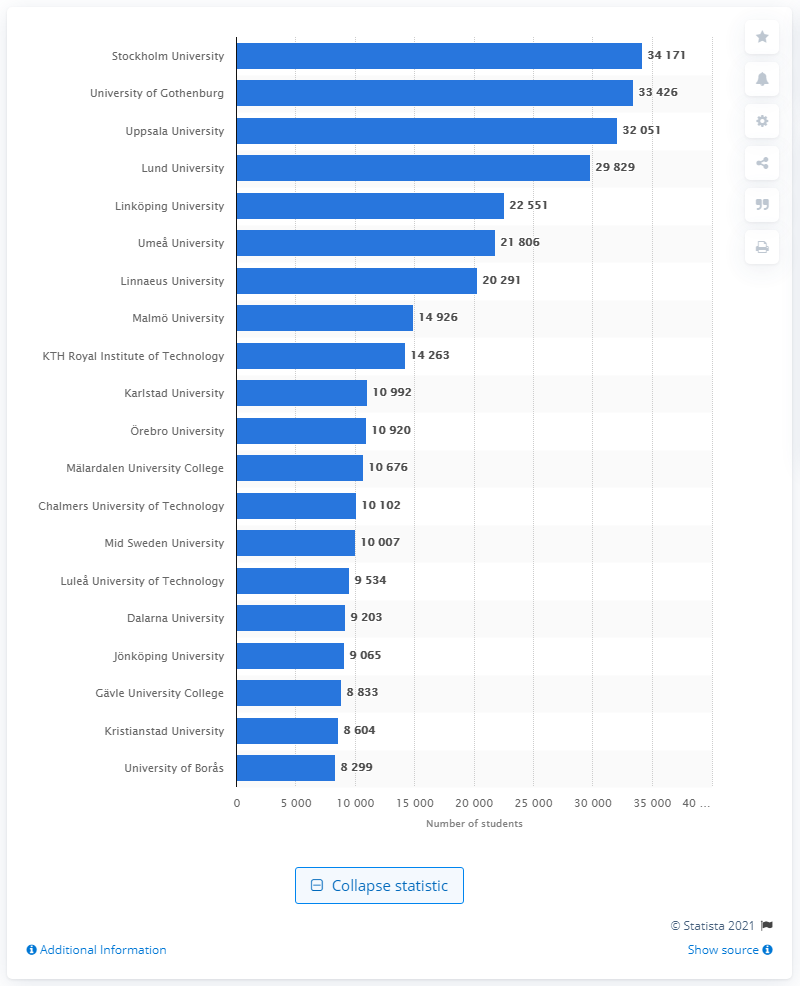Draw attention to some important aspects in this diagram. Stockholm University is ranked among the world's top 100 universities. In 2019, 34,171 students were registered at Stockholm University. 